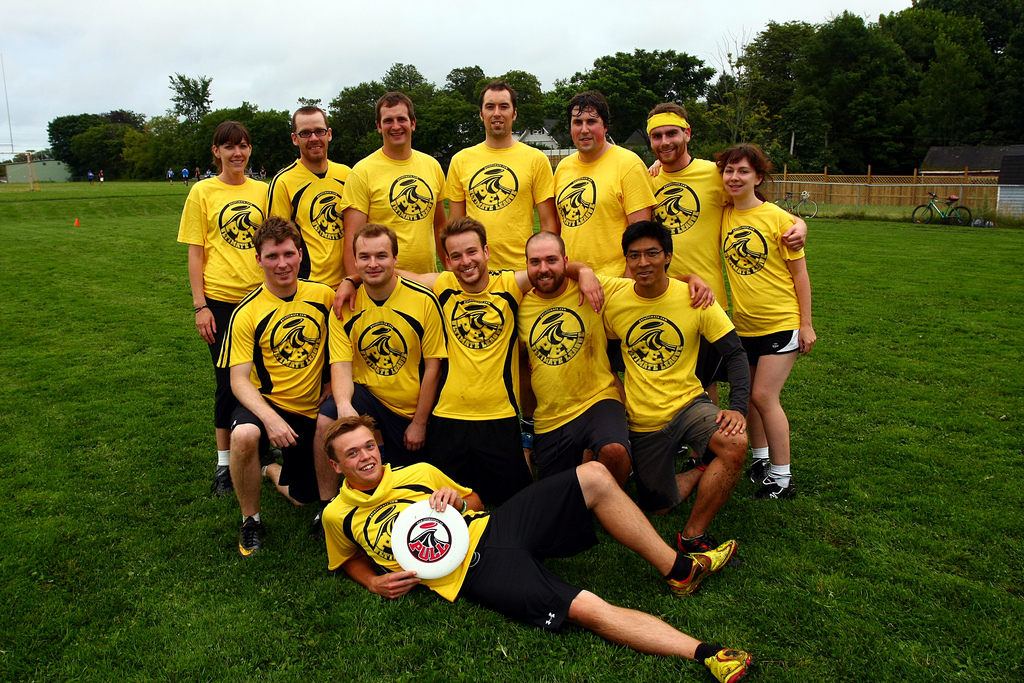How many people are lying down? Based on the image, there is 1 person lying down. This individual appears relaxed and seems to be enjoying a break, perhaps after participating in a group activity such as a sports game, evidenced by the matching uniforms of the group. 